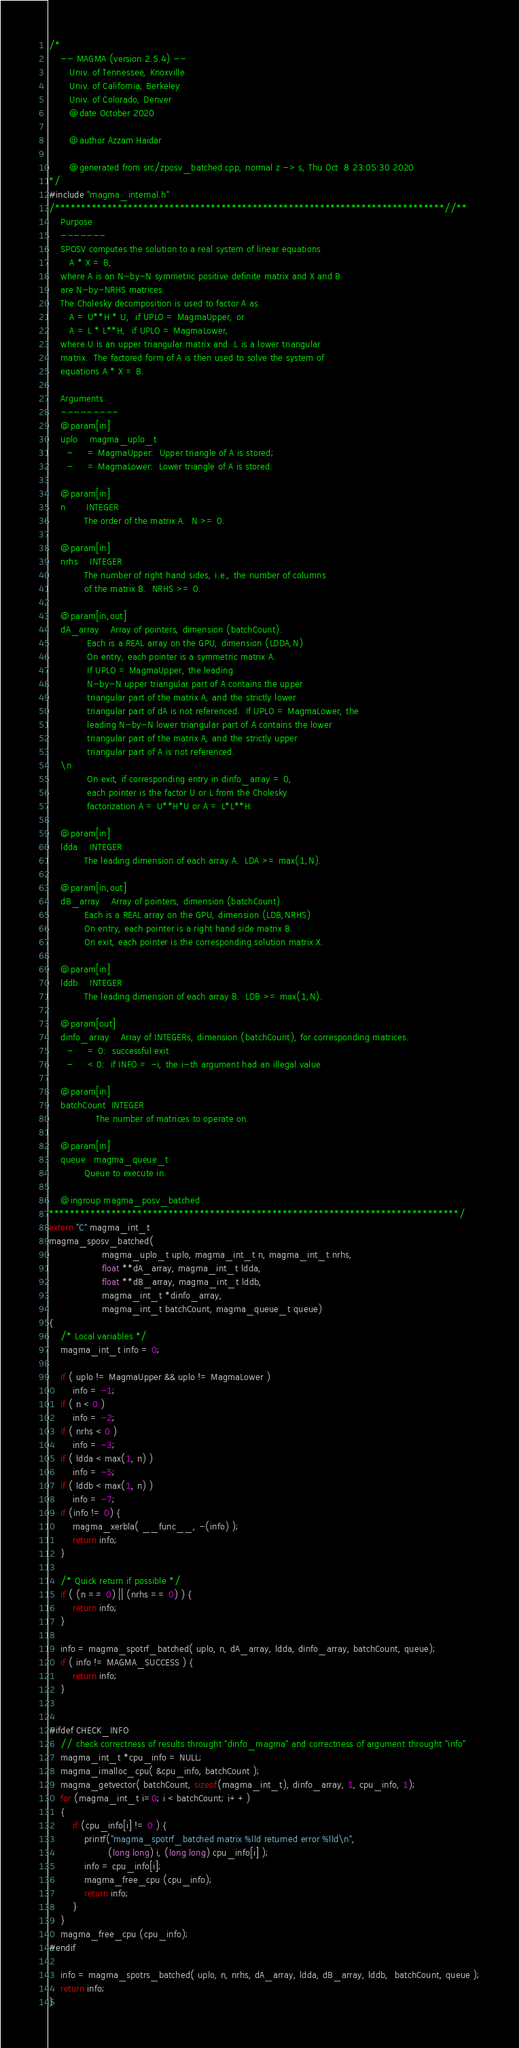<code> <loc_0><loc_0><loc_500><loc_500><_C++_>/*
    -- MAGMA (version 2.5.4) --
       Univ. of Tennessee, Knoxville
       Univ. of California, Berkeley
       Univ. of Colorado, Denver
       @date October 2020
       
       @author Azzam Haidar

       @generated from src/zposv_batched.cpp, normal z -> s, Thu Oct  8 23:05:30 2020
*/
#include "magma_internal.h"
/***************************************************************************//**
    Purpose
    -------
    SPOSV computes the solution to a real system of linear equations
       A * X = B,
    where A is an N-by-N symmetric positive definite matrix and X and B
    are N-by-NRHS matrices.
    The Cholesky decomposition is used to factor A as
       A = U**H * U,  if UPLO = MagmaUpper, or
       A = L * L**H,  if UPLO = MagmaLower,
    where U is an upper triangular matrix and  L is a lower triangular
    matrix.  The factored form of A is then used to solve the system of
    equations A * X = B.

    Arguments
    ---------
    @param[in]
    uplo    magma_uplo_t
      -     = MagmaUpper:  Upper triangle of A is stored;
      -     = MagmaLower:  Lower triangle of A is stored.

    @param[in]
    n       INTEGER
            The order of the matrix A.  N >= 0.

    @param[in]
    nrhs    INTEGER
            The number of right hand sides, i.e., the number of columns
            of the matrix B.  NRHS >= 0.

    @param[in,out]
    dA_array    Array of pointers, dimension (batchCount).
             Each is a REAL array on the GPU, dimension (LDDA,N)
             On entry, each pointer is a symmetric matrix A.  
             If UPLO = MagmaUpper, the leading
             N-by-N upper triangular part of A contains the upper
             triangular part of the matrix A, and the strictly lower
             triangular part of dA is not referenced.  If UPLO = MagmaLower, the
             leading N-by-N lower triangular part of A contains the lower
             triangular part of the matrix A, and the strictly upper
             triangular part of A is not referenced.
    \n
             On exit, if corresponding entry in dinfo_array = 0, 
             each pointer is the factor U or L from the Cholesky
             factorization A = U**H*U or A = L*L**H.

    @param[in]
    ldda    INTEGER
            The leading dimension of each array A.  LDA >= max(1,N).

    @param[in,out]
    dB_array    Array of pointers, dimension (batchCount).
            Each is a REAL array on the GPU, dimension (LDB,NRHS)
            On entry, each pointer is a right hand side matrix B.
            On exit, each pointer is the corresponding solution matrix X.

    @param[in]
    lddb    INTEGER
            The leading dimension of each array B.  LDB >= max(1,N).

    @param[out]
    dinfo_array    Array of INTEGERs, dimension (batchCount), for corresponding matrices.
      -     = 0:  successful exit
      -     < 0:  if INFO = -i, the i-th argument had an illegal value
    
    @param[in]
    batchCount  INTEGER
                The number of matrices to operate on.
    
    @param[in]
    queue   magma_queue_t
            Queue to execute in.

    @ingroup magma_posv_batched
*******************************************************************************/
extern "C" magma_int_t
magma_sposv_batched(
                  magma_uplo_t uplo, magma_int_t n, magma_int_t nrhs,
                  float **dA_array, magma_int_t ldda,
                  float **dB_array, magma_int_t lddb,
                  magma_int_t *dinfo_array,
                  magma_int_t batchCount, magma_queue_t queue)
{
    /* Local variables */
    magma_int_t info = 0;

    if ( uplo != MagmaUpper && uplo != MagmaLower )
        info = -1;
    if ( n < 0 )
        info = -2;
    if ( nrhs < 0 )
        info = -3;
    if ( ldda < max(1, n) )
        info = -5;
    if ( lddb < max(1, n) )
        info = -7;
    if (info != 0) {
        magma_xerbla( __func__, -(info) );
        return info;
    }

    /* Quick return if possible */
    if ( (n == 0) || (nrhs == 0) ) {
        return info;
    }

    info = magma_spotrf_batched( uplo, n, dA_array, ldda, dinfo_array, batchCount, queue);
    if ( info != MAGMA_SUCCESS ) {
        return info;
    }


#ifdef CHECK_INFO
    // check correctness of results throught "dinfo_magma" and correctness of argument throught "info"
    magma_int_t *cpu_info = NULL;
    magma_imalloc_cpu( &cpu_info, batchCount );
    magma_getvector( batchCount, sizeof(magma_int_t), dinfo_array, 1, cpu_info, 1);
    for (magma_int_t i=0; i < batchCount; i++)
    {
        if (cpu_info[i] != 0 ) {
            printf("magma_spotrf_batched matrix %lld returned error %lld\n",
                    (long long) i, (long long) cpu_info[i] );
            info = cpu_info[i];
            magma_free_cpu (cpu_info);
            return info;
        }
    }
    magma_free_cpu (cpu_info);
#endif

    info = magma_spotrs_batched( uplo, n, nrhs, dA_array, ldda, dB_array, lddb,  batchCount, queue );
    return info;
}
</code> 